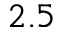<formula> <loc_0><loc_0><loc_500><loc_500>2 . 5</formula> 